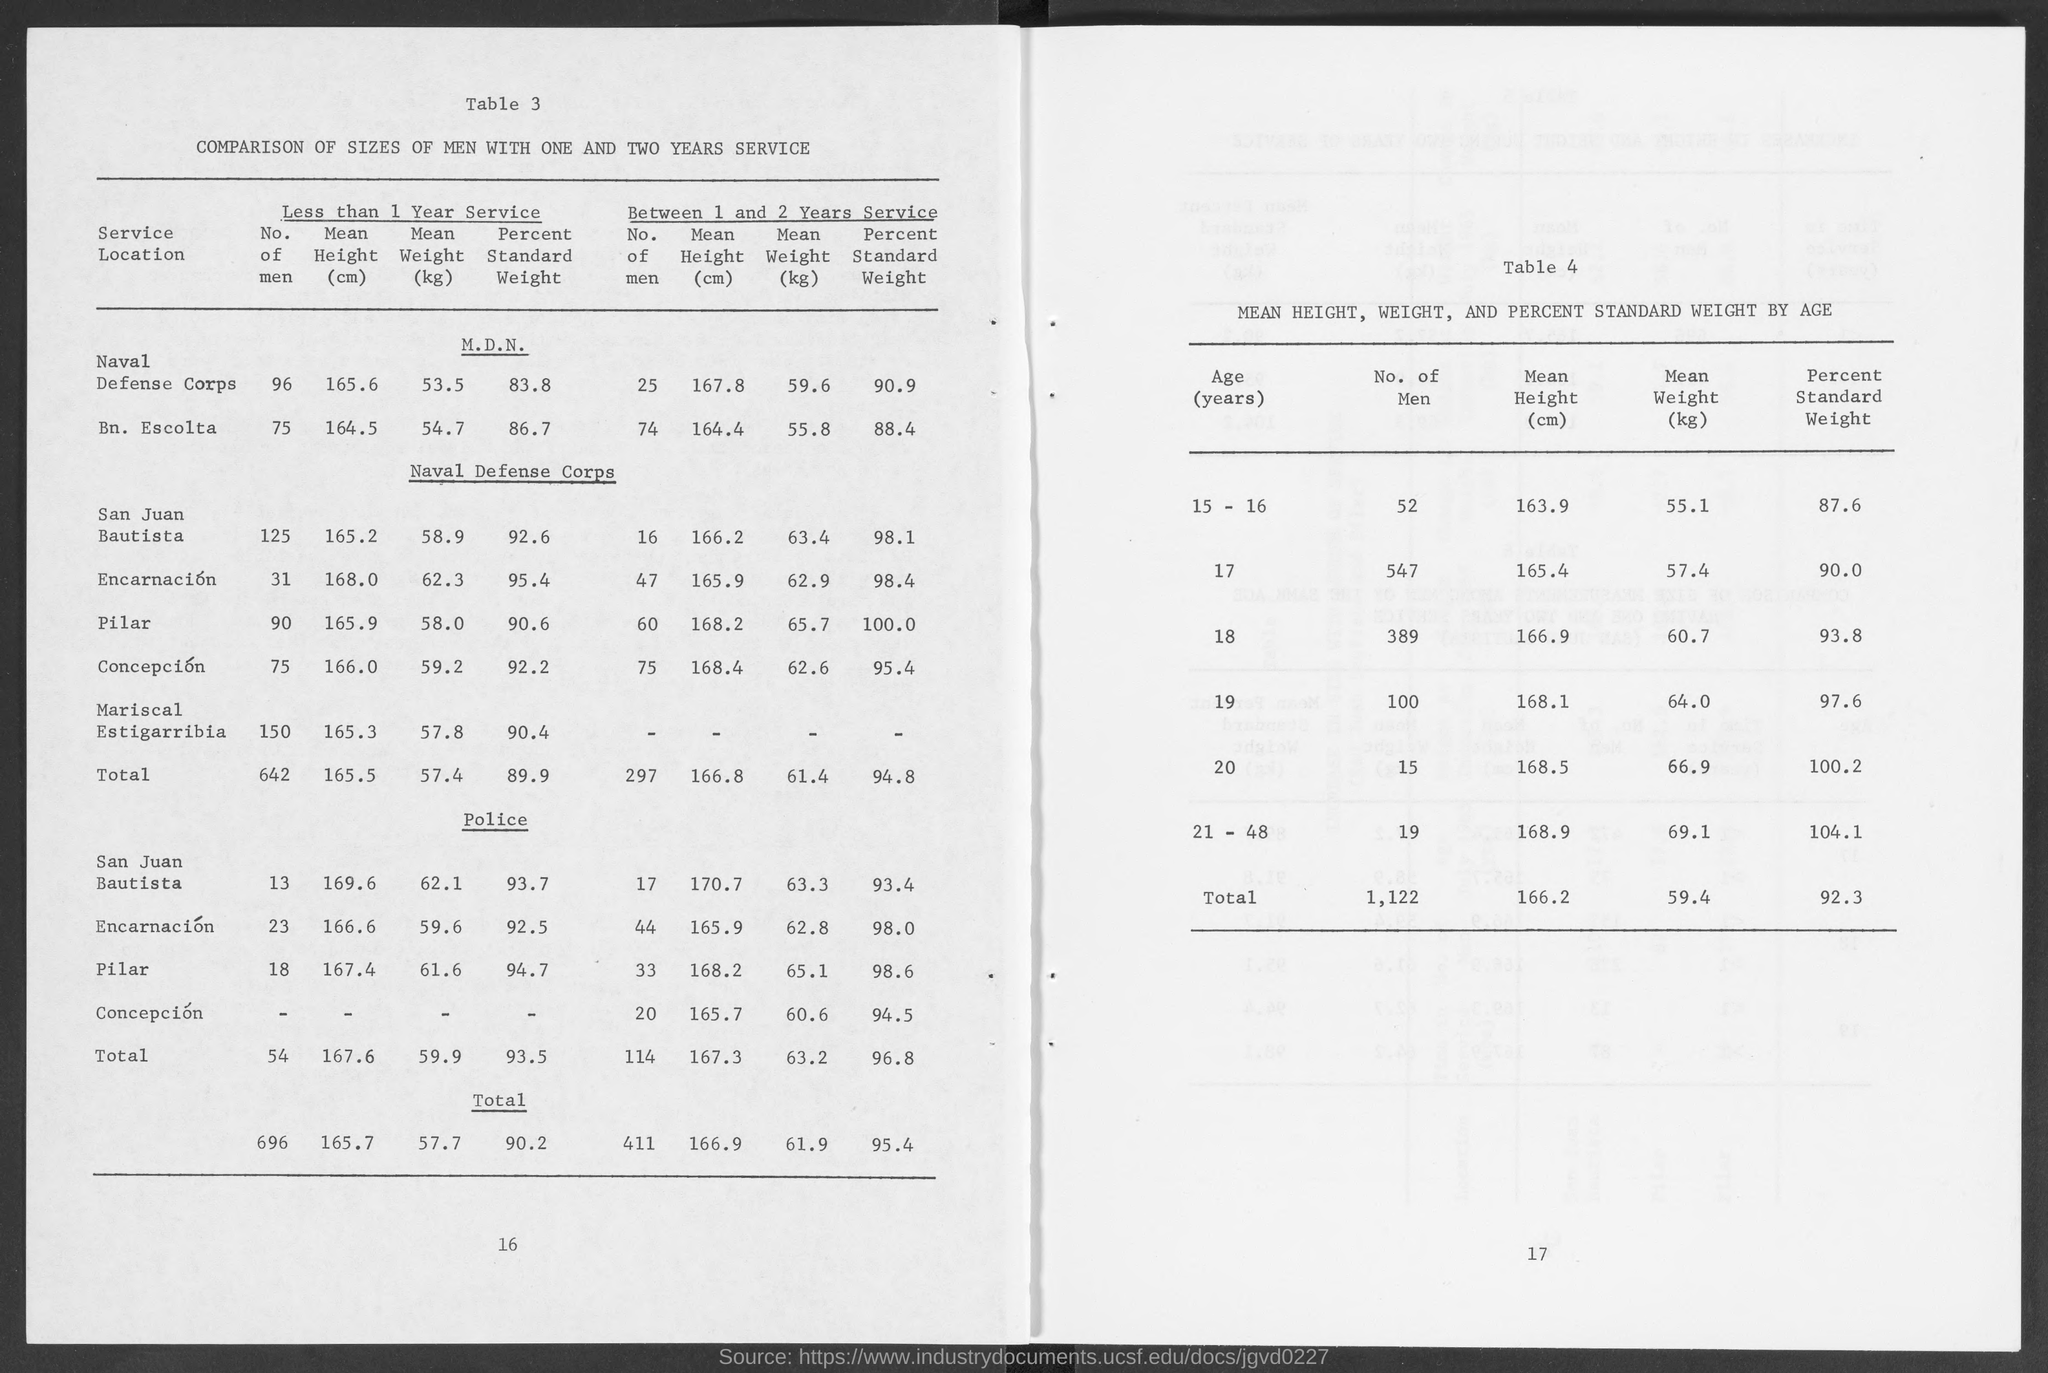What is the title of the table 3?
Your answer should be very brief. COMPARISON OF SIZES OF MEN WITH ONE AND TWO YEARS SERVICE. Which service location has highest value of mean height of persons with less than 1 year service?
Your response must be concise. San Juan Bautista. What is the title of table 4?
Ensure brevity in your answer.  MEAN HEIGHT, WEIGHT, AND PERCENT STANDARD WEIGHT BY AGE. Which age group had maximum no. of men?
Offer a very short reply. 17. What is the percent standard weight corresponding to oldest age group?
Offer a very short reply. 104.1. 